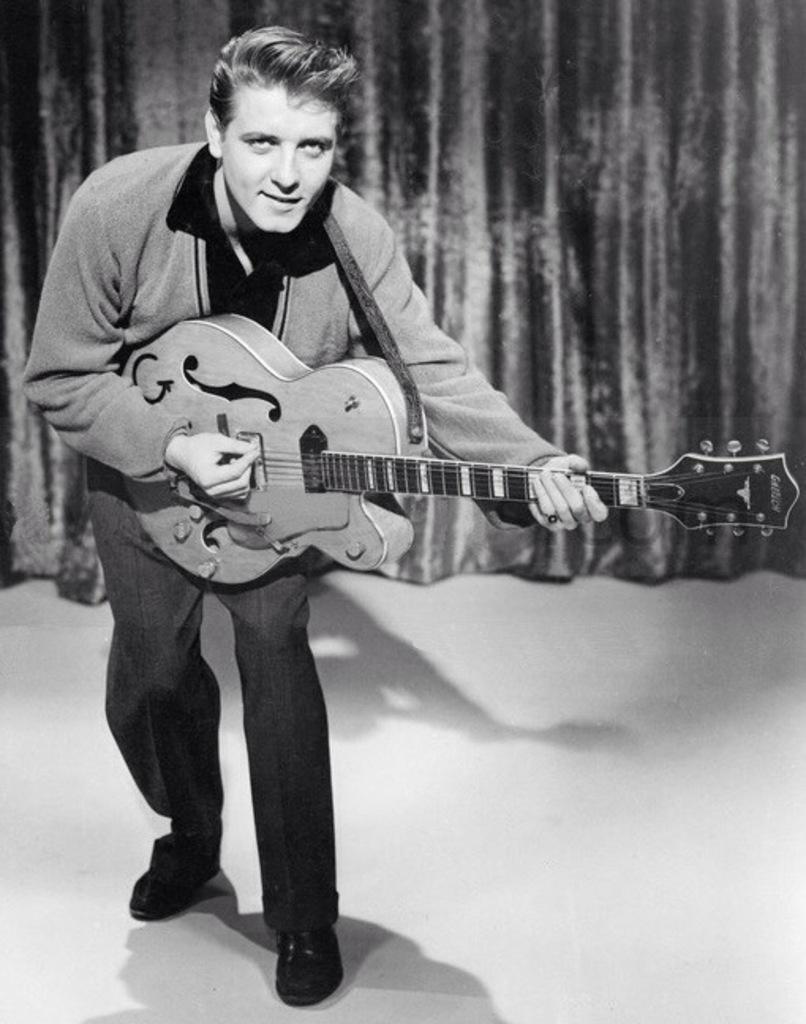Can you describe this image briefly? The person is playing guitar and there is a curtain behind him. 